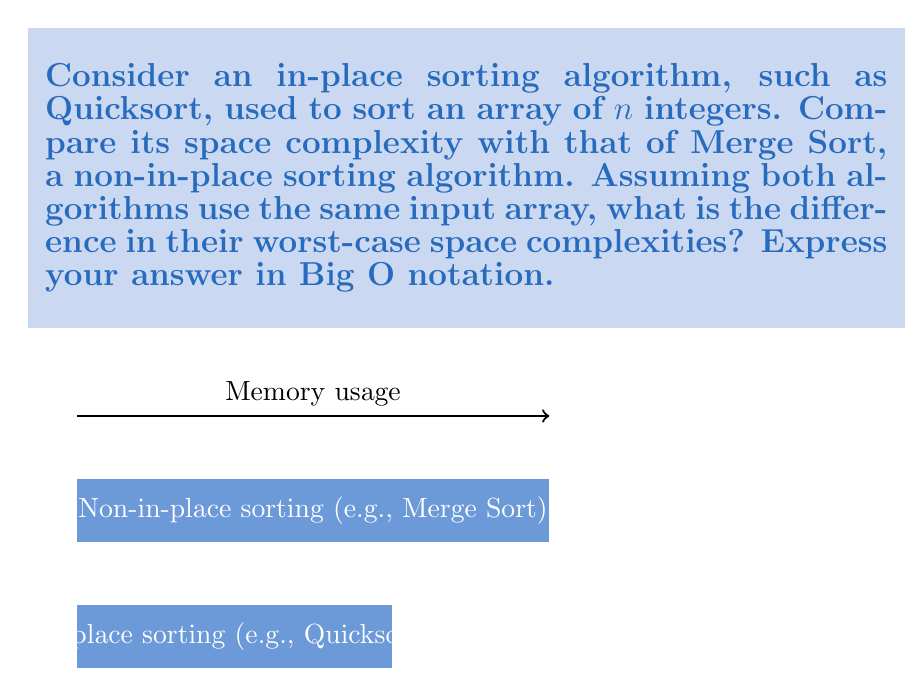What is the answer to this math problem? To solve this problem, let's analyze the space complexities of both algorithms:

1. In-place sorting algorithm (Quicksort):
   - Quicksort is an in-place sorting algorithm, which means it doesn't require significant extra space proportional to the input size.
   - It uses a small, constant amount of extra space for its operations, typically for the recursive call stack.
   - The worst-case space complexity of Quicksort is $O(\log n)$ due to the recursion depth.

2. Non-in-place sorting algorithm (Merge Sort):
   - Merge Sort is not an in-place sorting algorithm and requires additional space proportional to the input size.
   - It creates temporary arrays to merge sorted subarrays, which can be as large as the input array.
   - The worst-case space complexity of Merge Sort is $O(n)$, where $n$ is the number of elements in the input array.

3. Comparing the space complexities:
   - Quicksort (in-place): $O(\log n)$
   - Merge Sort (non-in-place): $O(n)$

4. To find the difference in worst-case space complexities:
   $O(n) - O(\log n) = O(n)$

The difference in space complexity is dominated by the larger term, $O(n)$, as $n$ grows larger.
Answer: $O(n)$ 